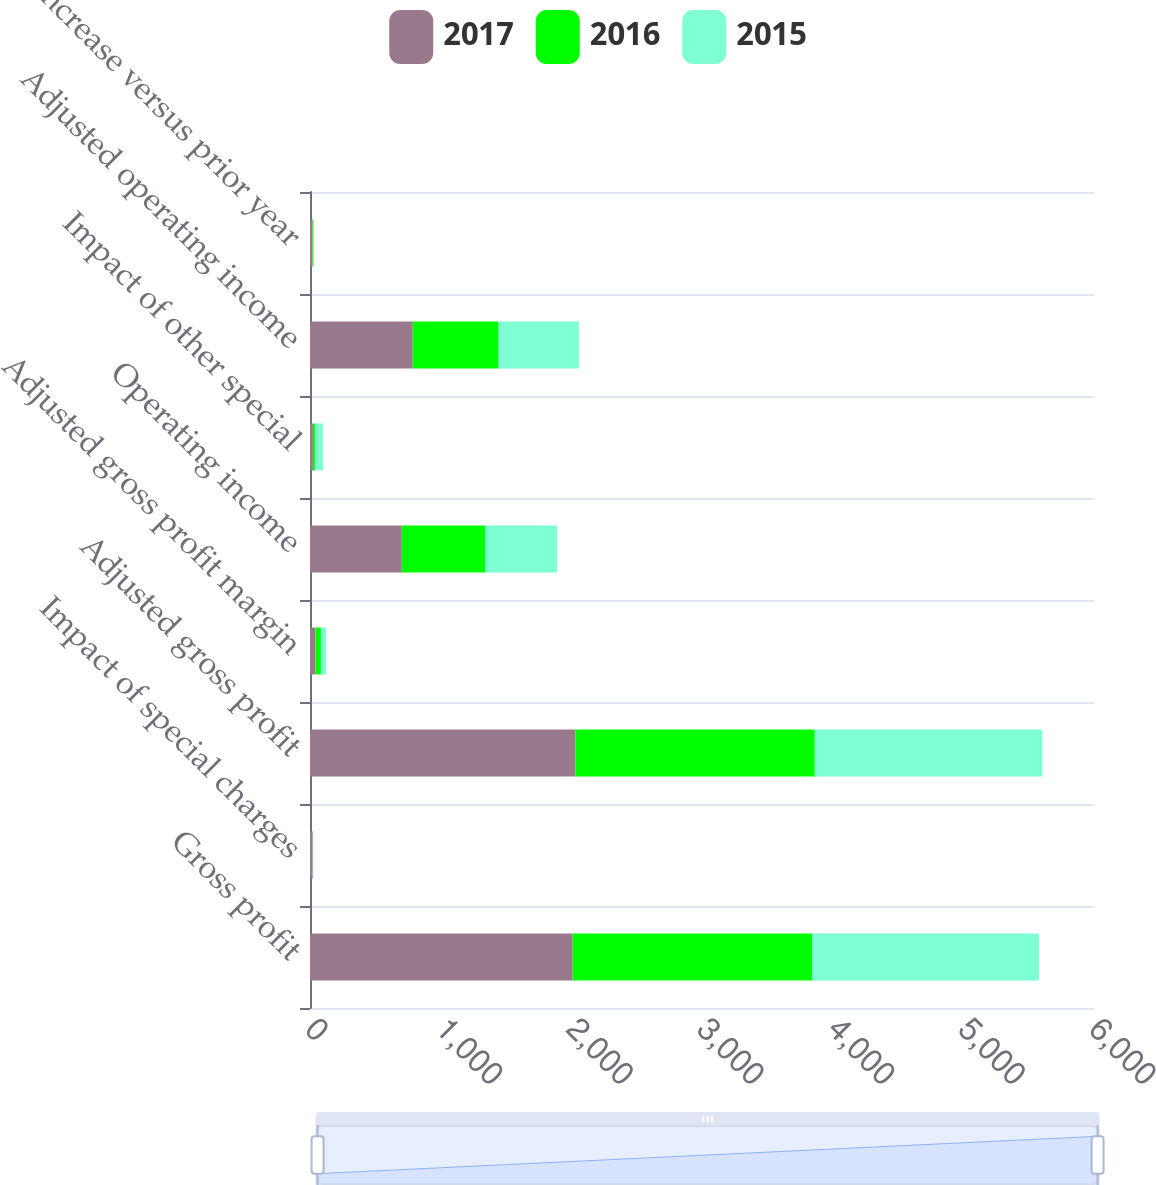Convert chart. <chart><loc_0><loc_0><loc_500><loc_500><stacked_bar_chart><ecel><fcel>Gross profit<fcel>Impact of special charges<fcel>Adjusted gross profit<fcel>Adjusted gross profit margin<fcel>Operating income<fcel>Impact of other special<fcel>Adjusted operating income<fcel>increase versus prior year<nl><fcel>2017<fcel>2010.2<fcel>20.9<fcel>2031.1<fcel>42<fcel>702.4<fcel>22.2<fcel>786.3<fcel>19.7<nl><fcel>2016<fcel>1831.7<fcel>0.3<fcel>1832<fcel>41.5<fcel>641<fcel>15.7<fcel>657<fcel>7<nl><fcel>2015<fcel>1737.3<fcel>4<fcel>1741.3<fcel>40.5<fcel>548.4<fcel>61.5<fcel>613.9<fcel>0.9<nl></chart> 